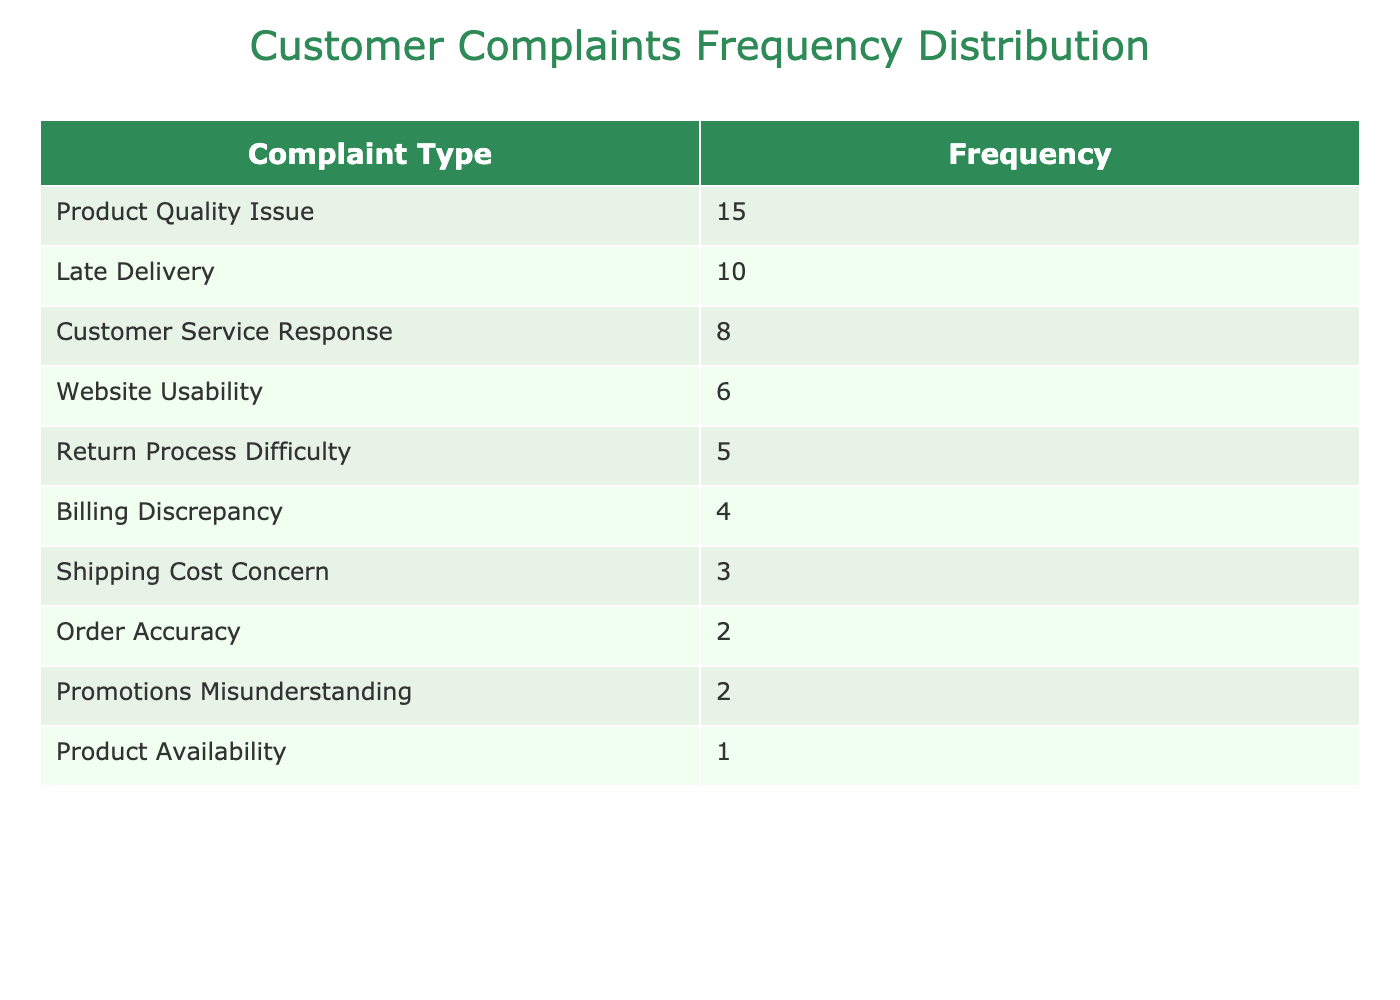What is the frequency of complaints regarding product quality? The table lists the complaint type “Product Quality Issue” along with its frequency of 15.
Answer: 15 What are the two most common types of customer complaints? By examining the frequency column, the highest frequency is for “Product Quality Issue” (15), followed by “Late Delivery” (10).
Answer: Product Quality Issue, Late Delivery How many total complaints were recorded in the last quarter? To find the total complaints, sum up all the frequencies: 15 + 10 + 8 + 4 + 6 + 5 + 3 + 2 + 1 + 2 = 56.
Answer: 56 Is the complaint about shipping costs more frequent than complaints regarding order accuracy? The frequency for “Shipping Cost Concern” is 3 and for “Order Accuracy” is 2. Since 3 is greater than 2, the statement is true.
Answer: Yes What is the average frequency of complaints for the categories listed? To calculate the average, sum all frequencies (56) and divide by the number of complaint types listed (10): 56 / 10 = 5.6.
Answer: 5.6 How many more complaints were received for product quality compared to website usability? The frequency for “Product Quality Issue” is 15 and for “Website Usability” is 6. The difference is 15 - 6 = 9 complaints.
Answer: 9 Which complaint type has the least frequency, and what is that frequency? The table shows that "Product Availability" has the least frequency of only 1 complaint.
Answer: Product Availability, 1 Are there any complaints related to promotions, and how many were recorded? Yes, the table includes "Promotions Misunderstanding" with a frequency of 2, indicating there were complaints recorded.
Answer: 2 What is the total frequency of complaints related to customer service and return processes? Adding the frequencies for “Customer Service Response” (8) and “Return Process Difficulty” (5) gives a total of 8 + 5 = 13 complaints.
Answer: 13 